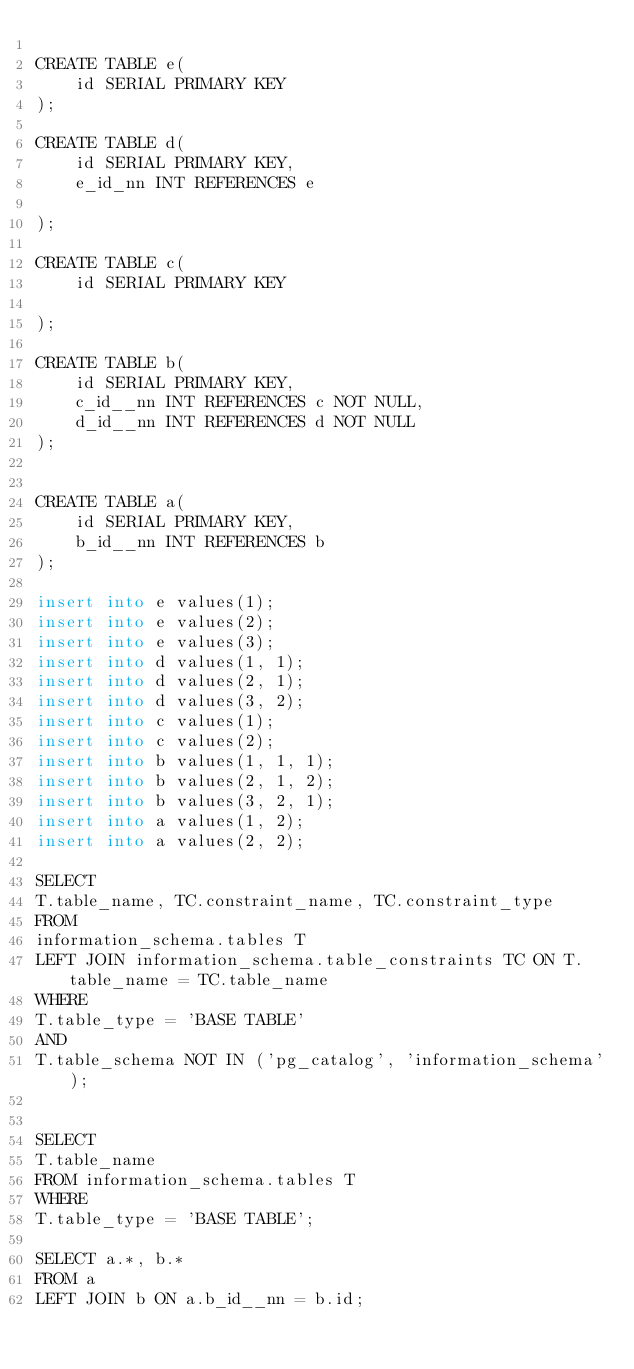Convert code to text. <code><loc_0><loc_0><loc_500><loc_500><_SQL_>
CREATE TABLE e(
    id SERIAL PRIMARY KEY
);

CREATE TABLE d(
    id SERIAL PRIMARY KEY,
    e_id_nn INT REFERENCES e

);

CREATE TABLE c(
    id SERIAL PRIMARY KEY

);

CREATE TABLE b(
    id SERIAL PRIMARY KEY,
    c_id__nn INT REFERENCES c NOT NULL,
    d_id__nn INT REFERENCES d NOT NULL
);


CREATE TABLE a(
    id SERIAL PRIMARY KEY,
    b_id__nn INT REFERENCES b
);

insert into e values(1);
insert into e values(2);
insert into e values(3);
insert into d values(1, 1);
insert into d values(2, 1);
insert into d values(3, 2);
insert into c values(1);
insert into c values(2);
insert into b values(1, 1, 1);
insert into b values(2, 1, 2);
insert into b values(3, 2, 1);
insert into a values(1, 2);
insert into a values(2, 2);

SELECT
T.table_name, TC.constraint_name, TC.constraint_type
FROM
information_schema.tables T
LEFT JOIN information_schema.table_constraints TC ON T.table_name = TC.table_name
WHERE
T.table_type = 'BASE TABLE'
AND
T.table_schema NOT IN ('pg_catalog', 'information_schema');


SELECT
T.table_name
FROM information_schema.tables T
WHERE
T.table_type = 'BASE TABLE';

SELECT a.*, b.*
FROM a
LEFT JOIN b ON a.b_id__nn = b.id;
</code> 